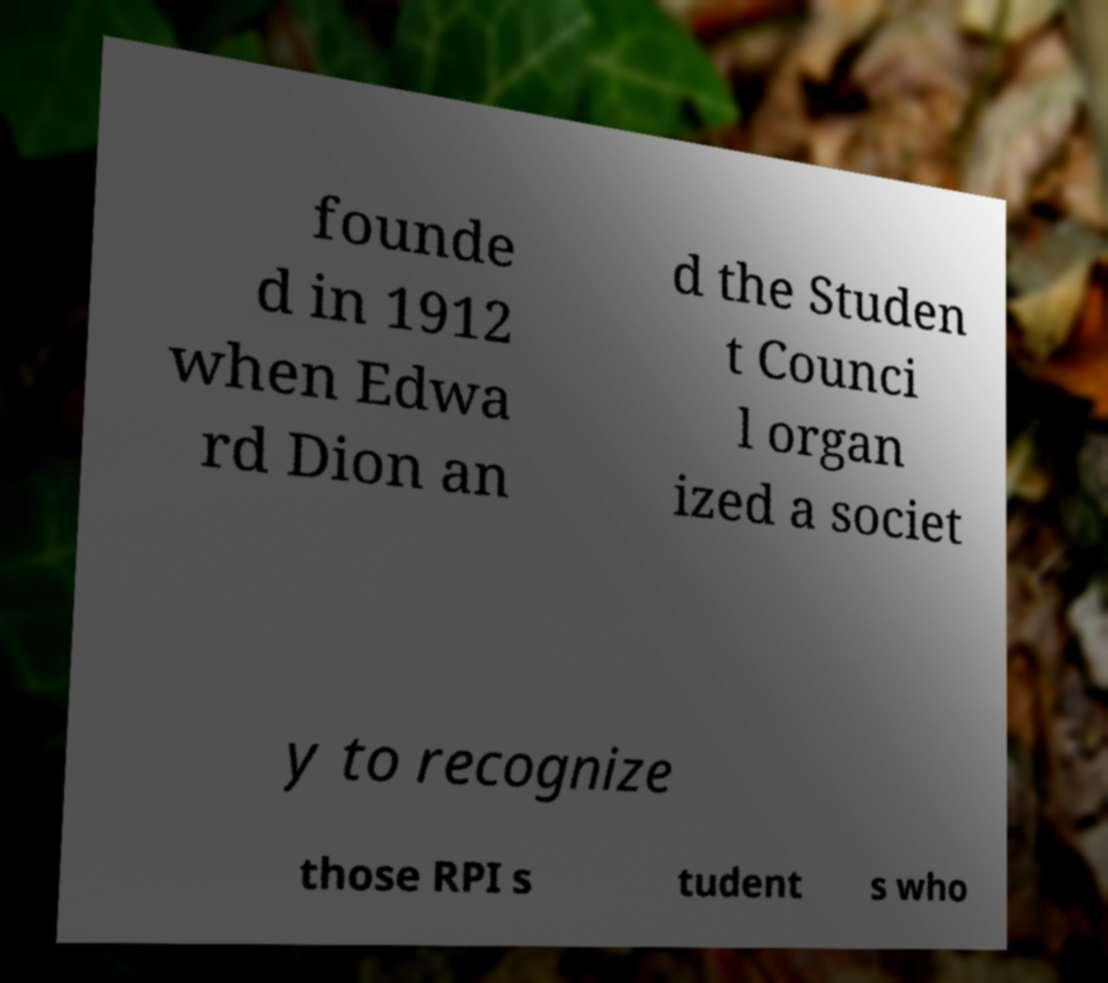I need the written content from this picture converted into text. Can you do that? founde d in 1912 when Edwa rd Dion an d the Studen t Counci l organ ized a societ y to recognize those RPI s tudent s who 